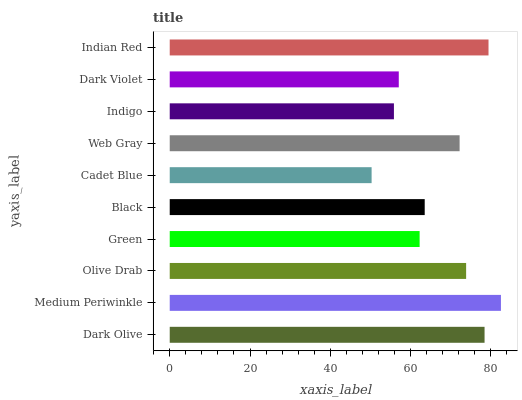Is Cadet Blue the minimum?
Answer yes or no. Yes. Is Medium Periwinkle the maximum?
Answer yes or no. Yes. Is Olive Drab the minimum?
Answer yes or no. No. Is Olive Drab the maximum?
Answer yes or no. No. Is Medium Periwinkle greater than Olive Drab?
Answer yes or no. Yes. Is Olive Drab less than Medium Periwinkle?
Answer yes or no. Yes. Is Olive Drab greater than Medium Periwinkle?
Answer yes or no. No. Is Medium Periwinkle less than Olive Drab?
Answer yes or no. No. Is Web Gray the high median?
Answer yes or no. Yes. Is Black the low median?
Answer yes or no. Yes. Is Black the high median?
Answer yes or no. No. Is Indian Red the low median?
Answer yes or no. No. 